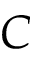<formula> <loc_0><loc_0><loc_500><loc_500>C</formula> 